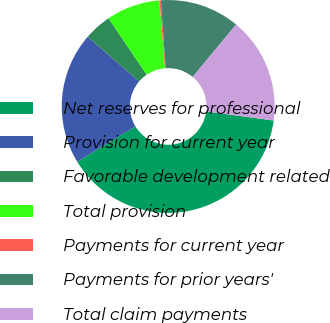Convert chart to OTSL. <chart><loc_0><loc_0><loc_500><loc_500><pie_chart><fcel>Net reserves for professional<fcel>Provision for current year<fcel>Favorable development related<fcel>Total provision<fcel>Payments for current year<fcel>Payments for prior years'<fcel>Total claim payments<nl><fcel>39.21%<fcel>20.04%<fcel>4.18%<fcel>8.15%<fcel>0.22%<fcel>12.11%<fcel>16.08%<nl></chart> 